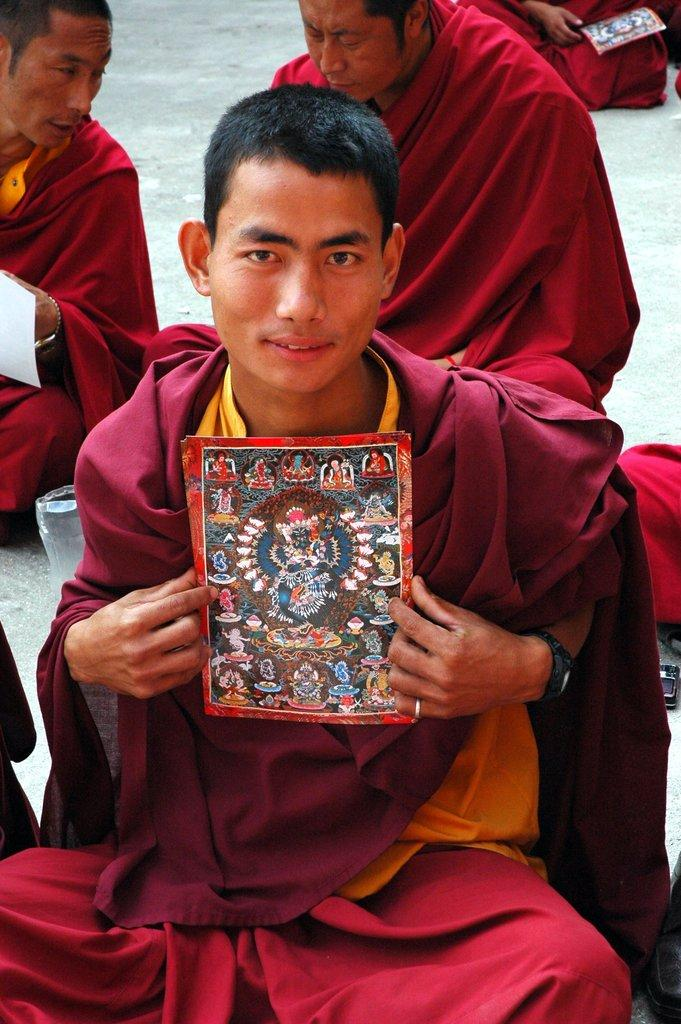What is the main subject of the image? The main subject of the image is a saint in a red costume. What is the saint doing in the image? The saint is sitting and holding a paper in his hands. Are there any other saints in the image? Yes, there are other saints in the image. What are the other saints doing in the image? The other saints are sitting and talking among themselves. What type of doll can be seen on the stage in the image? There is no doll or stage present in the image; it features saints sitting and talking. 